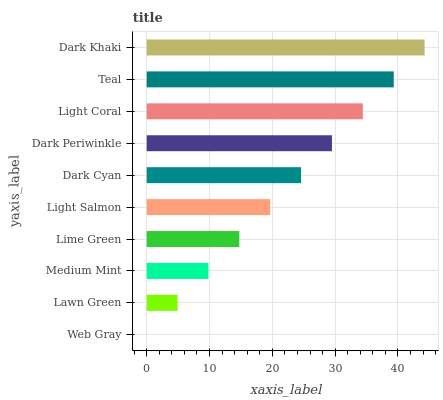Is Web Gray the minimum?
Answer yes or no. Yes. Is Dark Khaki the maximum?
Answer yes or no. Yes. Is Lawn Green the minimum?
Answer yes or no. No. Is Lawn Green the maximum?
Answer yes or no. No. Is Lawn Green greater than Web Gray?
Answer yes or no. Yes. Is Web Gray less than Lawn Green?
Answer yes or no. Yes. Is Web Gray greater than Lawn Green?
Answer yes or no. No. Is Lawn Green less than Web Gray?
Answer yes or no. No. Is Dark Cyan the high median?
Answer yes or no. Yes. Is Light Salmon the low median?
Answer yes or no. Yes. Is Light Salmon the high median?
Answer yes or no. No. Is Dark Periwinkle the low median?
Answer yes or no. No. 